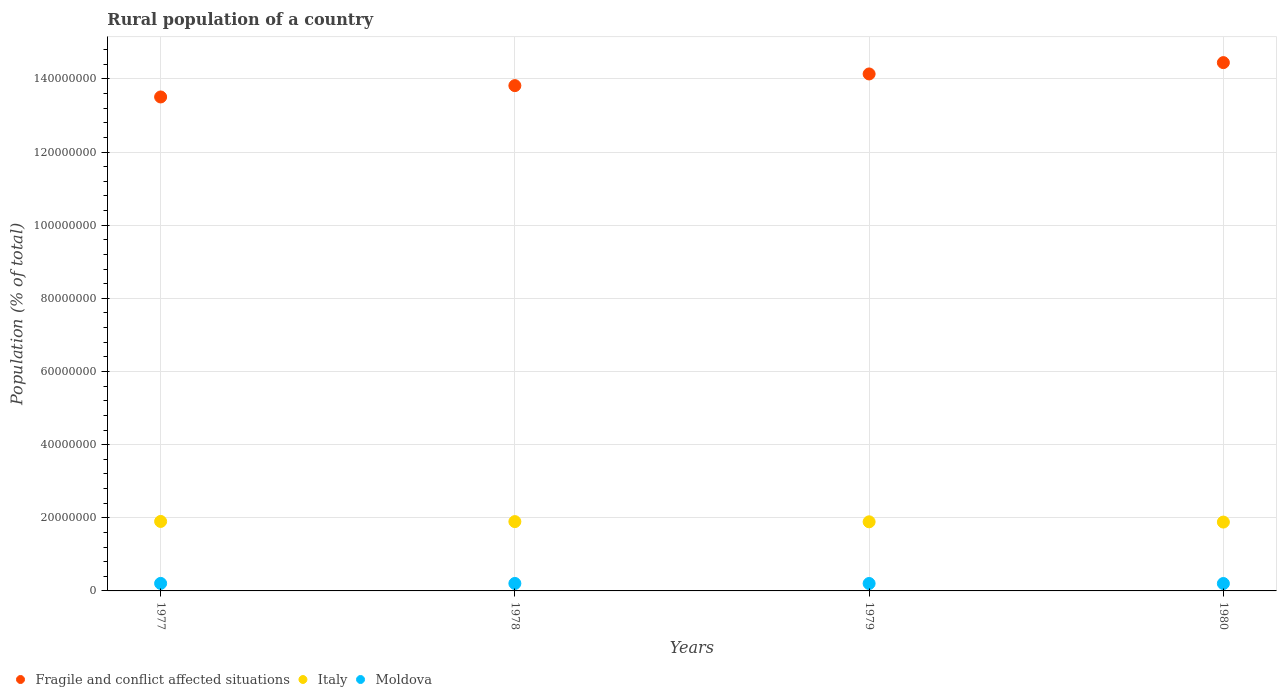How many different coloured dotlines are there?
Offer a very short reply. 3. Is the number of dotlines equal to the number of legend labels?
Your answer should be compact. Yes. What is the rural population in Italy in 1979?
Your answer should be compact. 1.89e+07. Across all years, what is the maximum rural population in Italy?
Offer a very short reply. 1.90e+07. Across all years, what is the minimum rural population in Moldova?
Your answer should be compact. 2.02e+06. In which year was the rural population in Fragile and conflict affected situations minimum?
Provide a succinct answer. 1977. What is the total rural population in Italy in the graph?
Keep it short and to the point. 7.57e+07. What is the difference between the rural population in Italy in 1977 and that in 1980?
Your answer should be very brief. 1.74e+05. What is the difference between the rural population in Italy in 1980 and the rural population in Moldova in 1977?
Provide a succinct answer. 1.68e+07. What is the average rural population in Fragile and conflict affected situations per year?
Provide a succinct answer. 1.40e+08. In the year 1979, what is the difference between the rural population in Moldova and rural population in Italy?
Your response must be concise. -1.69e+07. In how many years, is the rural population in Moldova greater than 120000000 %?
Keep it short and to the point. 0. What is the ratio of the rural population in Moldova in 1977 to that in 1979?
Give a very brief answer. 1.01. Is the rural population in Fragile and conflict affected situations in 1978 less than that in 1980?
Provide a short and direct response. Yes. Is the difference between the rural population in Moldova in 1978 and 1980 greater than the difference between the rural population in Italy in 1978 and 1980?
Keep it short and to the point. No. What is the difference between the highest and the second highest rural population in Fragile and conflict affected situations?
Give a very brief answer. 3.10e+06. What is the difference between the highest and the lowest rural population in Italy?
Your answer should be compact. 1.74e+05. In how many years, is the rural population in Fragile and conflict affected situations greater than the average rural population in Fragile and conflict affected situations taken over all years?
Keep it short and to the point. 2. Is the sum of the rural population in Fragile and conflict affected situations in 1978 and 1979 greater than the maximum rural population in Moldova across all years?
Your answer should be very brief. Yes. Is the rural population in Fragile and conflict affected situations strictly greater than the rural population in Moldova over the years?
Offer a terse response. Yes. How many years are there in the graph?
Give a very brief answer. 4. What is the difference between two consecutive major ticks on the Y-axis?
Your response must be concise. 2.00e+07. Does the graph contain any zero values?
Offer a very short reply. No. Does the graph contain grids?
Ensure brevity in your answer.  Yes. Where does the legend appear in the graph?
Provide a short and direct response. Bottom left. What is the title of the graph?
Keep it short and to the point. Rural population of a country. Does "Eritrea" appear as one of the legend labels in the graph?
Provide a succinct answer. No. What is the label or title of the Y-axis?
Give a very brief answer. Population (% of total). What is the Population (% of total) of Fragile and conflict affected situations in 1977?
Give a very brief answer. 1.35e+08. What is the Population (% of total) in Italy in 1977?
Your response must be concise. 1.90e+07. What is the Population (% of total) of Moldova in 1977?
Provide a succinct answer. 2.06e+06. What is the Population (% of total) in Fragile and conflict affected situations in 1978?
Your answer should be compact. 1.38e+08. What is the Population (% of total) of Italy in 1978?
Your answer should be very brief. 1.90e+07. What is the Population (% of total) in Moldova in 1978?
Provide a short and direct response. 2.04e+06. What is the Population (% of total) of Fragile and conflict affected situations in 1979?
Your answer should be very brief. 1.41e+08. What is the Population (% of total) of Italy in 1979?
Provide a short and direct response. 1.89e+07. What is the Population (% of total) of Moldova in 1979?
Ensure brevity in your answer.  2.03e+06. What is the Population (% of total) in Fragile and conflict affected situations in 1980?
Keep it short and to the point. 1.44e+08. What is the Population (% of total) in Italy in 1980?
Ensure brevity in your answer.  1.88e+07. What is the Population (% of total) of Moldova in 1980?
Make the answer very short. 2.02e+06. Across all years, what is the maximum Population (% of total) of Fragile and conflict affected situations?
Provide a short and direct response. 1.44e+08. Across all years, what is the maximum Population (% of total) in Italy?
Give a very brief answer. 1.90e+07. Across all years, what is the maximum Population (% of total) of Moldova?
Provide a succinct answer. 2.06e+06. Across all years, what is the minimum Population (% of total) of Fragile and conflict affected situations?
Provide a succinct answer. 1.35e+08. Across all years, what is the minimum Population (% of total) of Italy?
Make the answer very short. 1.88e+07. Across all years, what is the minimum Population (% of total) in Moldova?
Offer a very short reply. 2.02e+06. What is the total Population (% of total) in Fragile and conflict affected situations in the graph?
Keep it short and to the point. 5.59e+08. What is the total Population (% of total) of Italy in the graph?
Keep it short and to the point. 7.57e+07. What is the total Population (% of total) of Moldova in the graph?
Provide a short and direct response. 8.15e+06. What is the difference between the Population (% of total) of Fragile and conflict affected situations in 1977 and that in 1978?
Offer a terse response. -3.10e+06. What is the difference between the Population (% of total) in Italy in 1977 and that in 1978?
Your answer should be very brief. 4.39e+04. What is the difference between the Population (% of total) of Moldova in 1977 and that in 1978?
Your answer should be very brief. 1.24e+04. What is the difference between the Population (% of total) in Fragile and conflict affected situations in 1977 and that in 1979?
Your answer should be compact. -6.29e+06. What is the difference between the Population (% of total) of Italy in 1977 and that in 1979?
Your answer should be very brief. 1.01e+05. What is the difference between the Population (% of total) of Moldova in 1977 and that in 1979?
Offer a very short reply. 2.34e+04. What is the difference between the Population (% of total) of Fragile and conflict affected situations in 1977 and that in 1980?
Your response must be concise. -9.39e+06. What is the difference between the Population (% of total) of Italy in 1977 and that in 1980?
Make the answer very short. 1.74e+05. What is the difference between the Population (% of total) of Moldova in 1977 and that in 1980?
Keep it short and to the point. 3.07e+04. What is the difference between the Population (% of total) of Fragile and conflict affected situations in 1978 and that in 1979?
Offer a very short reply. -3.19e+06. What is the difference between the Population (% of total) of Italy in 1978 and that in 1979?
Provide a succinct answer. 5.72e+04. What is the difference between the Population (% of total) in Moldova in 1978 and that in 1979?
Keep it short and to the point. 1.10e+04. What is the difference between the Population (% of total) of Fragile and conflict affected situations in 1978 and that in 1980?
Offer a terse response. -6.29e+06. What is the difference between the Population (% of total) in Italy in 1978 and that in 1980?
Make the answer very short. 1.30e+05. What is the difference between the Population (% of total) in Moldova in 1978 and that in 1980?
Offer a terse response. 1.83e+04. What is the difference between the Population (% of total) in Fragile and conflict affected situations in 1979 and that in 1980?
Ensure brevity in your answer.  -3.10e+06. What is the difference between the Population (% of total) in Italy in 1979 and that in 1980?
Provide a short and direct response. 7.28e+04. What is the difference between the Population (% of total) of Moldova in 1979 and that in 1980?
Provide a succinct answer. 7261. What is the difference between the Population (% of total) in Fragile and conflict affected situations in 1977 and the Population (% of total) in Italy in 1978?
Your response must be concise. 1.16e+08. What is the difference between the Population (% of total) of Fragile and conflict affected situations in 1977 and the Population (% of total) of Moldova in 1978?
Keep it short and to the point. 1.33e+08. What is the difference between the Population (% of total) of Italy in 1977 and the Population (% of total) of Moldova in 1978?
Offer a very short reply. 1.70e+07. What is the difference between the Population (% of total) in Fragile and conflict affected situations in 1977 and the Population (% of total) in Italy in 1979?
Give a very brief answer. 1.16e+08. What is the difference between the Population (% of total) in Fragile and conflict affected situations in 1977 and the Population (% of total) in Moldova in 1979?
Make the answer very short. 1.33e+08. What is the difference between the Population (% of total) of Italy in 1977 and the Population (% of total) of Moldova in 1979?
Your answer should be very brief. 1.70e+07. What is the difference between the Population (% of total) of Fragile and conflict affected situations in 1977 and the Population (% of total) of Italy in 1980?
Provide a short and direct response. 1.16e+08. What is the difference between the Population (% of total) of Fragile and conflict affected situations in 1977 and the Population (% of total) of Moldova in 1980?
Keep it short and to the point. 1.33e+08. What is the difference between the Population (% of total) of Italy in 1977 and the Population (% of total) of Moldova in 1980?
Offer a very short reply. 1.70e+07. What is the difference between the Population (% of total) of Fragile and conflict affected situations in 1978 and the Population (% of total) of Italy in 1979?
Offer a terse response. 1.19e+08. What is the difference between the Population (% of total) in Fragile and conflict affected situations in 1978 and the Population (% of total) in Moldova in 1979?
Provide a short and direct response. 1.36e+08. What is the difference between the Population (% of total) in Italy in 1978 and the Population (% of total) in Moldova in 1979?
Give a very brief answer. 1.69e+07. What is the difference between the Population (% of total) of Fragile and conflict affected situations in 1978 and the Population (% of total) of Italy in 1980?
Provide a succinct answer. 1.19e+08. What is the difference between the Population (% of total) of Fragile and conflict affected situations in 1978 and the Population (% of total) of Moldova in 1980?
Offer a terse response. 1.36e+08. What is the difference between the Population (% of total) in Italy in 1978 and the Population (% of total) in Moldova in 1980?
Give a very brief answer. 1.69e+07. What is the difference between the Population (% of total) of Fragile and conflict affected situations in 1979 and the Population (% of total) of Italy in 1980?
Provide a succinct answer. 1.23e+08. What is the difference between the Population (% of total) in Fragile and conflict affected situations in 1979 and the Population (% of total) in Moldova in 1980?
Provide a succinct answer. 1.39e+08. What is the difference between the Population (% of total) of Italy in 1979 and the Population (% of total) of Moldova in 1980?
Provide a succinct answer. 1.69e+07. What is the average Population (% of total) of Fragile and conflict affected situations per year?
Offer a terse response. 1.40e+08. What is the average Population (% of total) of Italy per year?
Give a very brief answer. 1.89e+07. What is the average Population (% of total) in Moldova per year?
Provide a short and direct response. 2.04e+06. In the year 1977, what is the difference between the Population (% of total) of Fragile and conflict affected situations and Population (% of total) of Italy?
Give a very brief answer. 1.16e+08. In the year 1977, what is the difference between the Population (% of total) in Fragile and conflict affected situations and Population (% of total) in Moldova?
Provide a succinct answer. 1.33e+08. In the year 1977, what is the difference between the Population (% of total) of Italy and Population (% of total) of Moldova?
Offer a very short reply. 1.69e+07. In the year 1978, what is the difference between the Population (% of total) in Fragile and conflict affected situations and Population (% of total) in Italy?
Your answer should be compact. 1.19e+08. In the year 1978, what is the difference between the Population (% of total) of Fragile and conflict affected situations and Population (% of total) of Moldova?
Offer a terse response. 1.36e+08. In the year 1978, what is the difference between the Population (% of total) of Italy and Population (% of total) of Moldova?
Give a very brief answer. 1.69e+07. In the year 1979, what is the difference between the Population (% of total) in Fragile and conflict affected situations and Population (% of total) in Italy?
Your response must be concise. 1.22e+08. In the year 1979, what is the difference between the Population (% of total) in Fragile and conflict affected situations and Population (% of total) in Moldova?
Your response must be concise. 1.39e+08. In the year 1979, what is the difference between the Population (% of total) in Italy and Population (% of total) in Moldova?
Offer a terse response. 1.69e+07. In the year 1980, what is the difference between the Population (% of total) in Fragile and conflict affected situations and Population (% of total) in Italy?
Offer a very short reply. 1.26e+08. In the year 1980, what is the difference between the Population (% of total) in Fragile and conflict affected situations and Population (% of total) in Moldova?
Offer a very short reply. 1.42e+08. In the year 1980, what is the difference between the Population (% of total) in Italy and Population (% of total) in Moldova?
Offer a terse response. 1.68e+07. What is the ratio of the Population (% of total) in Fragile and conflict affected situations in 1977 to that in 1978?
Your answer should be very brief. 0.98. What is the ratio of the Population (% of total) in Italy in 1977 to that in 1978?
Your answer should be very brief. 1. What is the ratio of the Population (% of total) in Moldova in 1977 to that in 1978?
Offer a terse response. 1.01. What is the ratio of the Population (% of total) in Fragile and conflict affected situations in 1977 to that in 1979?
Your answer should be compact. 0.96. What is the ratio of the Population (% of total) of Moldova in 1977 to that in 1979?
Give a very brief answer. 1.01. What is the ratio of the Population (% of total) in Fragile and conflict affected situations in 1977 to that in 1980?
Provide a succinct answer. 0.94. What is the ratio of the Population (% of total) in Italy in 1977 to that in 1980?
Your response must be concise. 1.01. What is the ratio of the Population (% of total) in Moldova in 1977 to that in 1980?
Provide a short and direct response. 1.02. What is the ratio of the Population (% of total) in Fragile and conflict affected situations in 1978 to that in 1979?
Make the answer very short. 0.98. What is the ratio of the Population (% of total) in Moldova in 1978 to that in 1979?
Provide a succinct answer. 1.01. What is the ratio of the Population (% of total) in Fragile and conflict affected situations in 1978 to that in 1980?
Your answer should be compact. 0.96. What is the ratio of the Population (% of total) in Fragile and conflict affected situations in 1979 to that in 1980?
Your answer should be compact. 0.98. What is the ratio of the Population (% of total) in Italy in 1979 to that in 1980?
Offer a terse response. 1. What is the difference between the highest and the second highest Population (% of total) in Fragile and conflict affected situations?
Make the answer very short. 3.10e+06. What is the difference between the highest and the second highest Population (% of total) in Italy?
Make the answer very short. 4.39e+04. What is the difference between the highest and the second highest Population (% of total) in Moldova?
Make the answer very short. 1.24e+04. What is the difference between the highest and the lowest Population (% of total) of Fragile and conflict affected situations?
Offer a terse response. 9.39e+06. What is the difference between the highest and the lowest Population (% of total) in Italy?
Your response must be concise. 1.74e+05. What is the difference between the highest and the lowest Population (% of total) of Moldova?
Your answer should be very brief. 3.07e+04. 